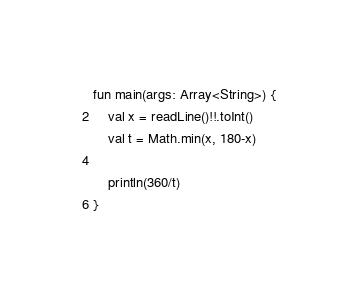Convert code to text. <code><loc_0><loc_0><loc_500><loc_500><_Kotlin_>fun main(args: Array<String>) {
    val x = readLine()!!.toInt()
    val t = Math.min(x, 180-x)

    println(360/t)
}
</code> 